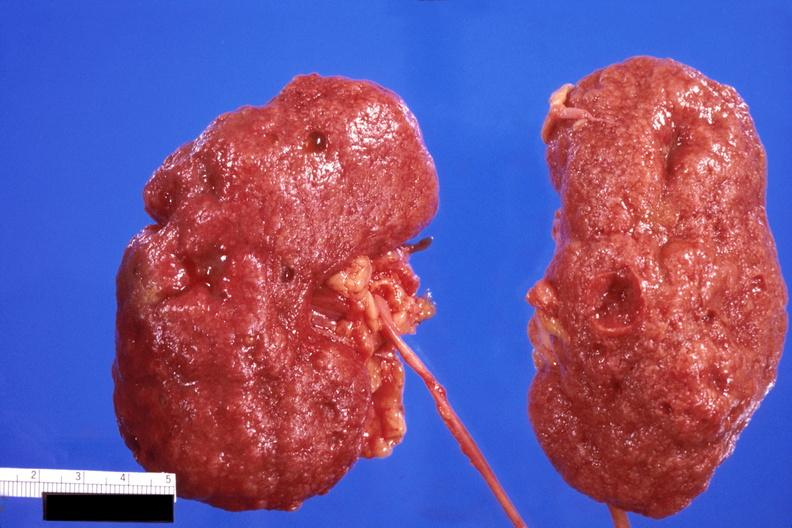what does this image show?
Answer the question using a single word or phrase. Kidney 